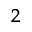Convert formula to latex. <formula><loc_0><loc_0><loc_500><loc_500>_ { 2 }</formula> 